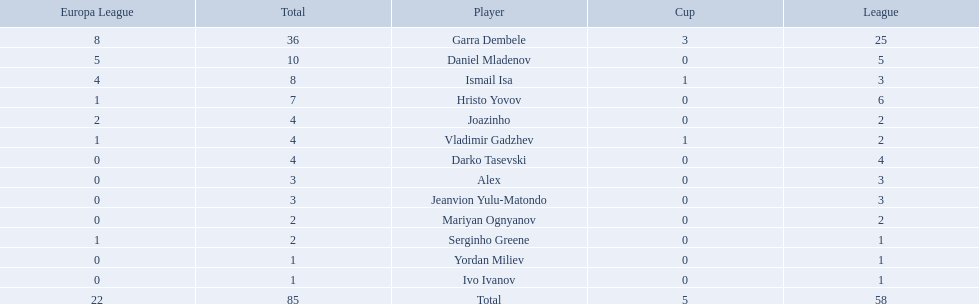What players did not score in all 3 competitions? Daniel Mladenov, Hristo Yovov, Joazinho, Darko Tasevski, Alex, Jeanvion Yulu-Matondo, Mariyan Ognyanov, Serginho Greene, Yordan Miliev, Ivo Ivanov. Which of those did not have total more then 5? Darko Tasevski, Alex, Jeanvion Yulu-Matondo, Mariyan Ognyanov, Serginho Greene, Yordan Miliev, Ivo Ivanov. Which ones scored more then 1 total? Darko Tasevski, Alex, Jeanvion Yulu-Matondo, Mariyan Ognyanov. Which of these player had the lease league points? Mariyan Ognyanov. 